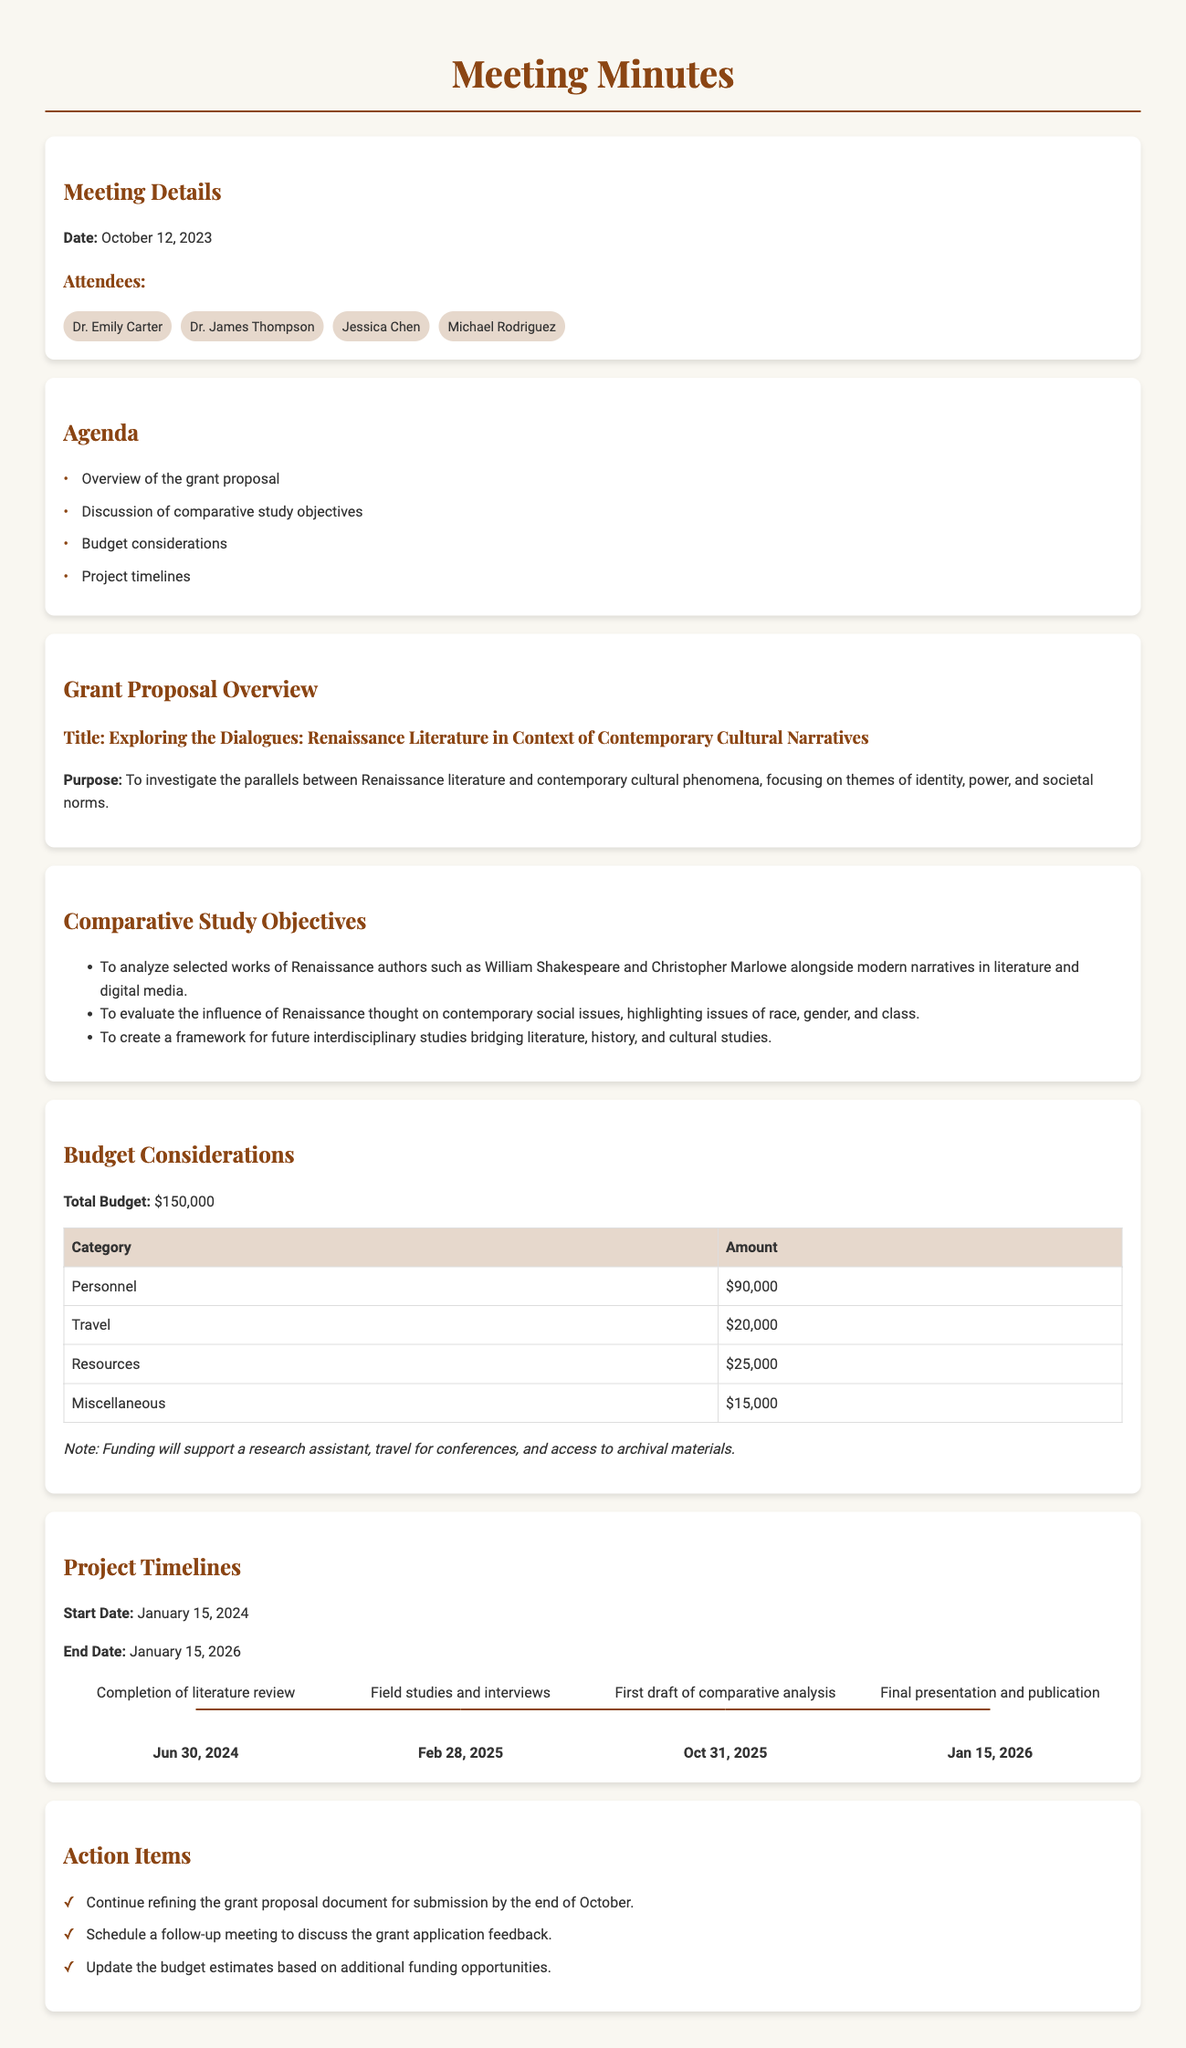What is the total budget for the grant proposal? The total budget is explicitly stated in the document, which sums up to $150,000.
Answer: $150,000 Who are the attendees of the meeting? The document lists the names of all attendees under the "Attendees" section, which includes Dr. Emily Carter, Dr. James Thompson, Jessica Chen, and Michael Rodriguez.
Answer: Dr. Emily Carter, Dr. James Thompson, Jessica Chen, Michael Rodriguez What is the start date of the project? The start date is provided in the "Project Timelines" section, which indicates it begins on January 15, 2024.
Answer: January 15, 2024 Which milestone is due on June 30, 2024? The document specifies this date in the "Project Timelines" section, where it states the completion of the literature review is due.
Answer: Completion of literature review What is the category with the highest budget allocation? The budget table indicates that the highest allocated amount is for personnel, which amounts to $90,000.
Answer: Personnel What is the purpose of the grant proposal? The purpose is clearly defined in the "Grant Proposal Overview" section, focusing on investigating parallels between historical and contemporary narratives.
Answer: To investigate the parallels between Renaissance literature and contemporary cultural phenomena What is the final milestone and its date? The last milestone mentioned is the final presentation and publication, which is due on January 15, 2026, as per the timeline.
Answer: Final presentation and publication What action item involves the grant proposal document? The first action item specifically mentions the need to refine the grant proposal document for submission.
Answer: Continue refining the grant proposal document for submission What are the themes focused on in the comparative study? The document outlines key themes such as identity, power, and societal norms that are explored within the study.
Answer: Identity, power, and societal norms 